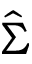<formula> <loc_0><loc_0><loc_500><loc_500>\hat { \Sigma }</formula> 